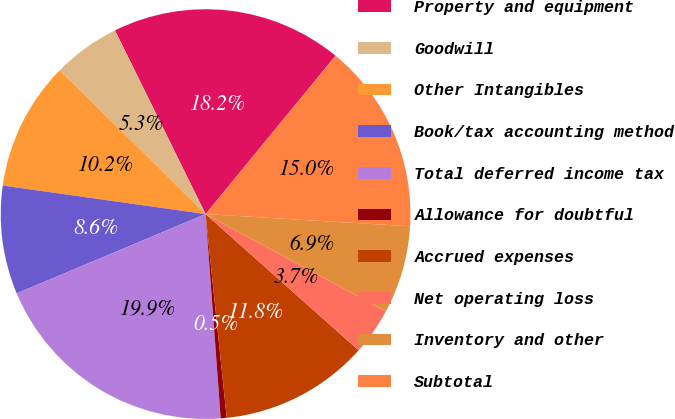Convert chart to OTSL. <chart><loc_0><loc_0><loc_500><loc_500><pie_chart><fcel>Property and equipment<fcel>Goodwill<fcel>Other Intangibles<fcel>Book/tax accounting method<fcel>Total deferred income tax<fcel>Allowance for doubtful<fcel>Accrued expenses<fcel>Net operating loss<fcel>Inventory and other<fcel>Subtotal<nl><fcel>18.23%<fcel>5.32%<fcel>10.16%<fcel>8.55%<fcel>19.85%<fcel>0.47%<fcel>11.78%<fcel>3.7%<fcel>6.93%<fcel>15.01%<nl></chart> 